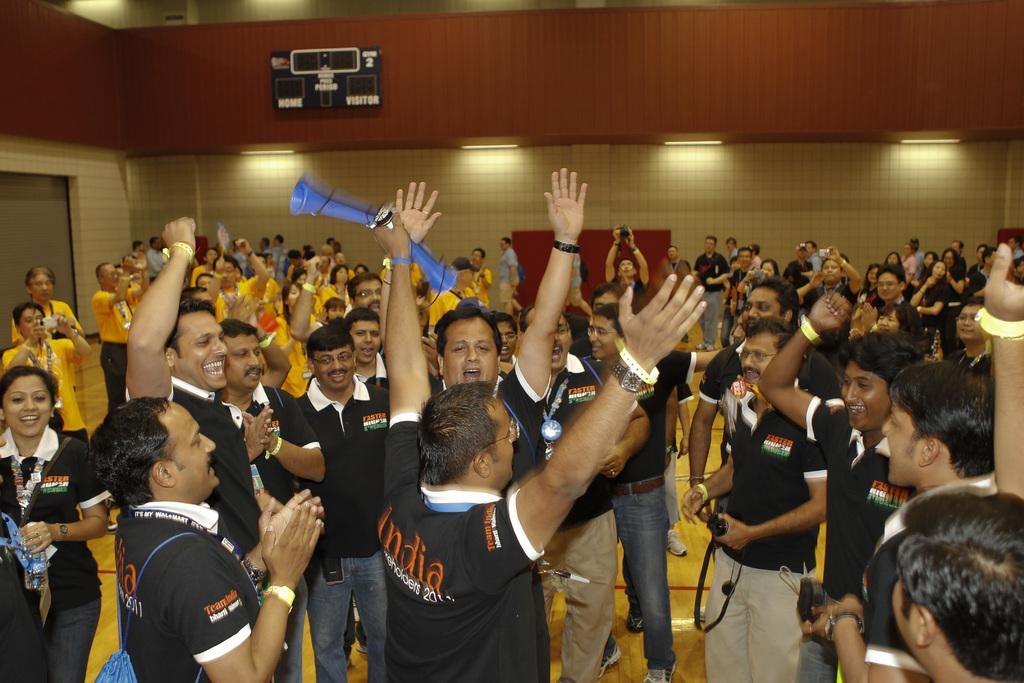Can you describe this image briefly? In this picture we can see a group of people on the ground, some people are holding cameras, one woman is holding a bottle, another person is holding objects and in the background we can see a wall, lights and some objects. 